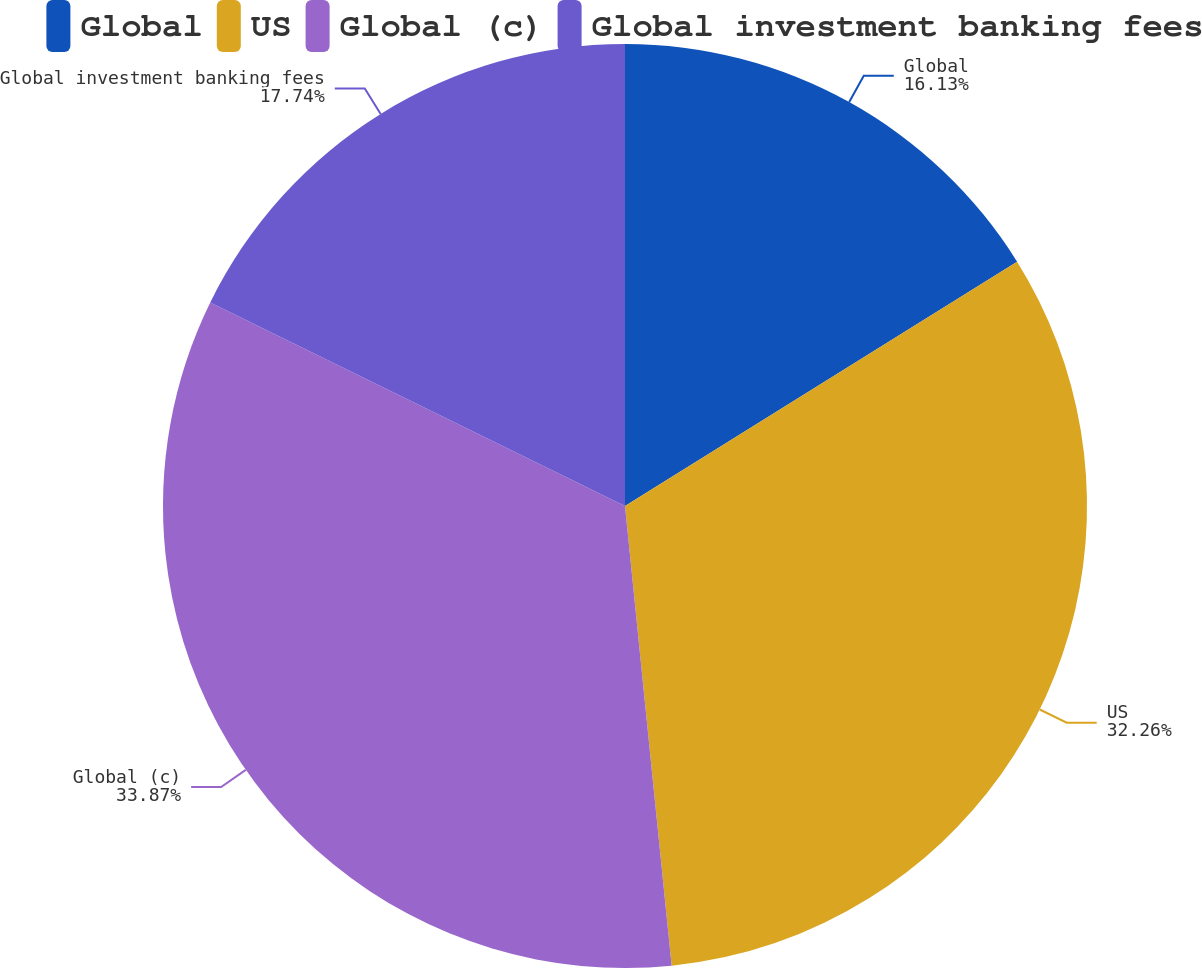Convert chart to OTSL. <chart><loc_0><loc_0><loc_500><loc_500><pie_chart><fcel>Global<fcel>US<fcel>Global (c)<fcel>Global investment banking fees<nl><fcel>16.13%<fcel>32.26%<fcel>33.87%<fcel>17.74%<nl></chart> 